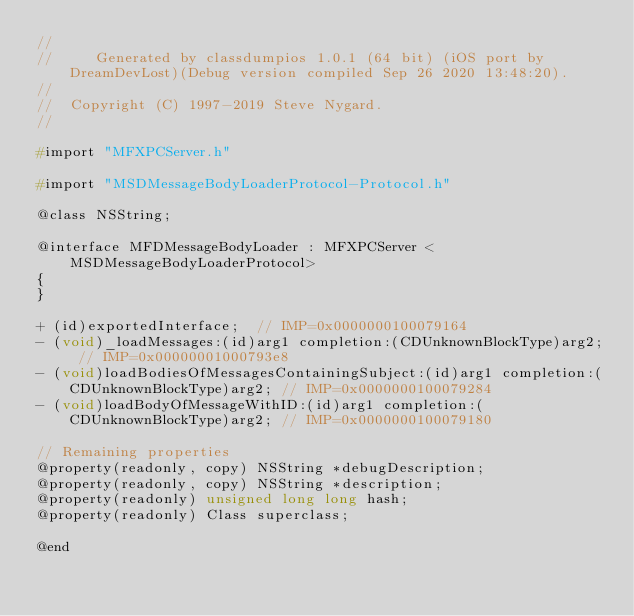Convert code to text. <code><loc_0><loc_0><loc_500><loc_500><_C_>//
//     Generated by classdumpios 1.0.1 (64 bit) (iOS port by DreamDevLost)(Debug version compiled Sep 26 2020 13:48:20).
//
//  Copyright (C) 1997-2019 Steve Nygard.
//

#import "MFXPCServer.h"

#import "MSDMessageBodyLoaderProtocol-Protocol.h"

@class NSString;

@interface MFDMessageBodyLoader : MFXPCServer <MSDMessageBodyLoaderProtocol>
{
}

+ (id)exportedInterface;	// IMP=0x0000000100079164
- (void)_loadMessages:(id)arg1 completion:(CDUnknownBlockType)arg2;	// IMP=0x00000001000793e8
- (void)loadBodiesOfMessagesContainingSubject:(id)arg1 completion:(CDUnknownBlockType)arg2;	// IMP=0x0000000100079284
- (void)loadBodyOfMessageWithID:(id)arg1 completion:(CDUnknownBlockType)arg2;	// IMP=0x0000000100079180

// Remaining properties
@property(readonly, copy) NSString *debugDescription;
@property(readonly, copy) NSString *description;
@property(readonly) unsigned long long hash;
@property(readonly) Class superclass;

@end

</code> 